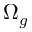<formula> <loc_0><loc_0><loc_500><loc_500>\Omega _ { g }</formula> 